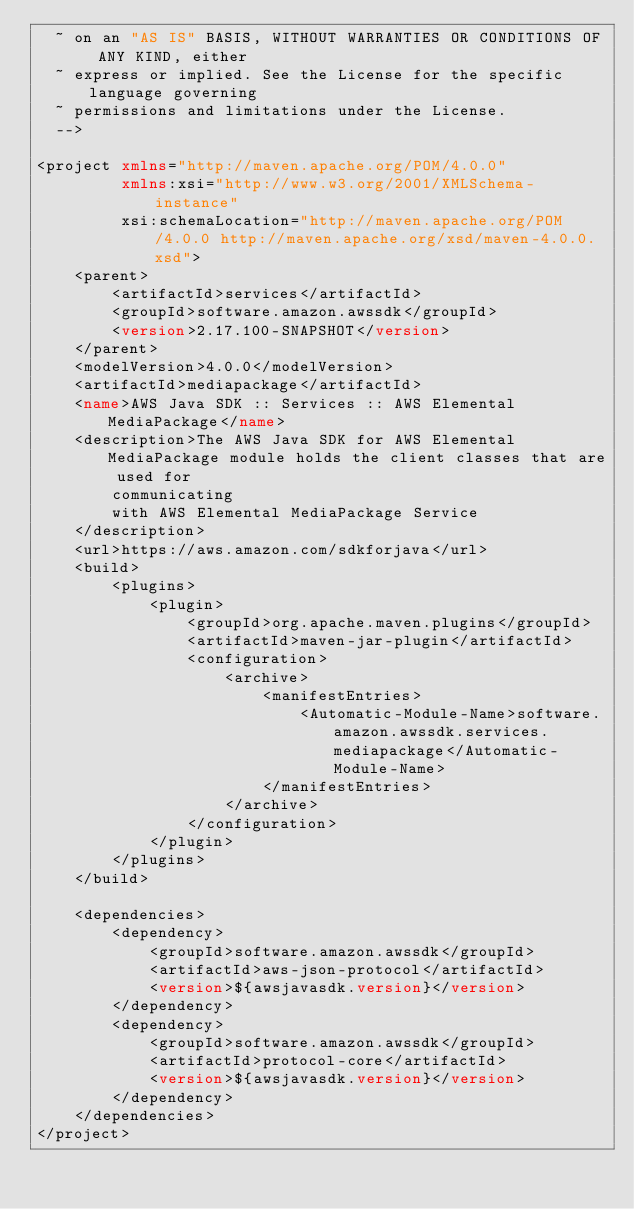<code> <loc_0><loc_0><loc_500><loc_500><_XML_>  ~ on an "AS IS" BASIS, WITHOUT WARRANTIES OR CONDITIONS OF ANY KIND, either
  ~ express or implied. See the License for the specific language governing
  ~ permissions and limitations under the License.
  -->

<project xmlns="http://maven.apache.org/POM/4.0.0"
         xmlns:xsi="http://www.w3.org/2001/XMLSchema-instance"
         xsi:schemaLocation="http://maven.apache.org/POM/4.0.0 http://maven.apache.org/xsd/maven-4.0.0.xsd">
    <parent>
        <artifactId>services</artifactId>
        <groupId>software.amazon.awssdk</groupId>
        <version>2.17.100-SNAPSHOT</version>
    </parent>
    <modelVersion>4.0.0</modelVersion>
    <artifactId>mediapackage</artifactId>
    <name>AWS Java SDK :: Services :: AWS Elemental MediaPackage</name>
    <description>The AWS Java SDK for AWS Elemental MediaPackage module holds the client classes that are used for
        communicating
        with AWS Elemental MediaPackage Service
    </description>
    <url>https://aws.amazon.com/sdkforjava</url>
    <build>
        <plugins>
            <plugin>
                <groupId>org.apache.maven.plugins</groupId>
                <artifactId>maven-jar-plugin</artifactId>
                <configuration>
                    <archive>
                        <manifestEntries>
                            <Automatic-Module-Name>software.amazon.awssdk.services.mediapackage</Automatic-Module-Name>
                        </manifestEntries>
                    </archive>
                </configuration>
            </plugin>
        </plugins>
    </build>

    <dependencies>
        <dependency>
            <groupId>software.amazon.awssdk</groupId>
            <artifactId>aws-json-protocol</artifactId>
            <version>${awsjavasdk.version}</version>
        </dependency>
        <dependency>
            <groupId>software.amazon.awssdk</groupId>
            <artifactId>protocol-core</artifactId>
            <version>${awsjavasdk.version}</version>
        </dependency>
    </dependencies>
</project>
</code> 